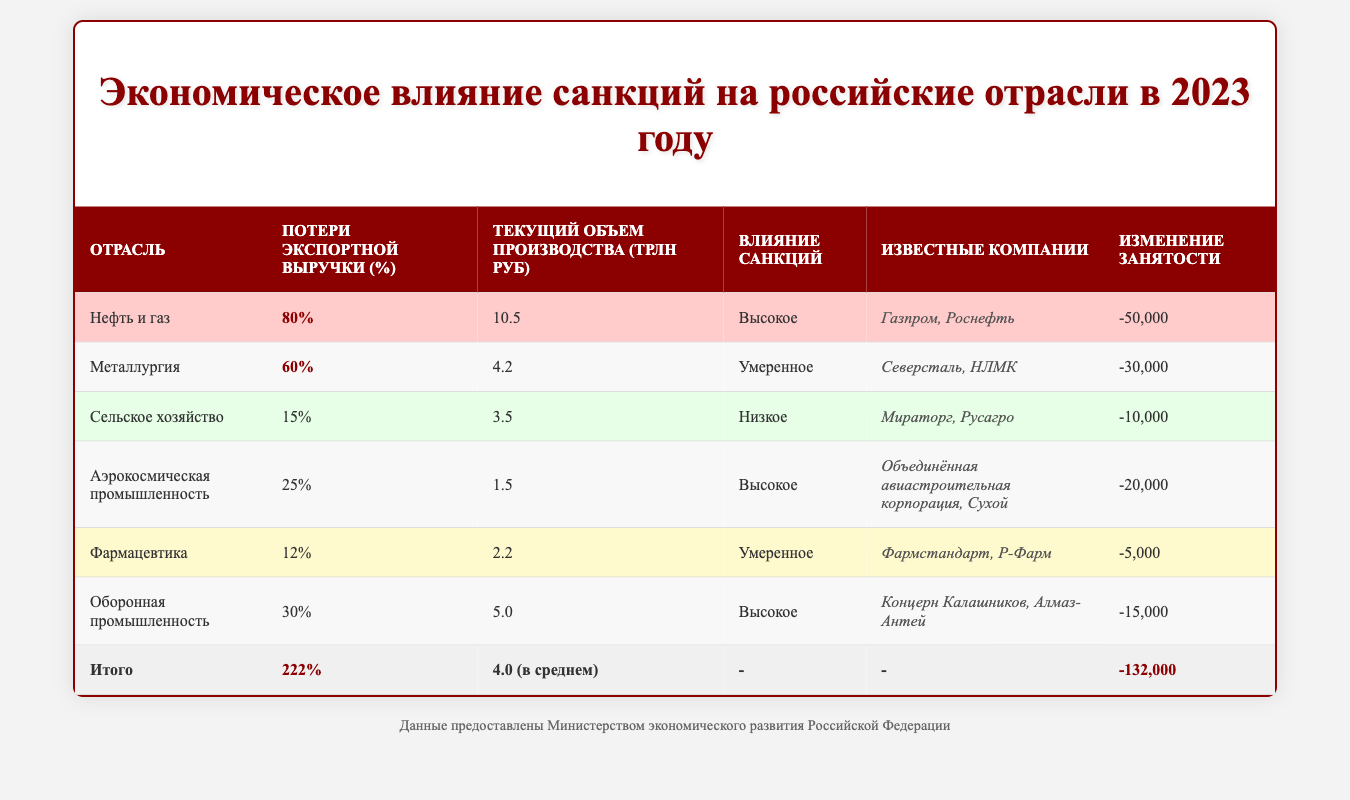What is the industry with the highest export revenue loss? The table indicates that the Oil and Gas industry has the highest export revenue loss at 80%.
Answer: Oil and Gas What is the total export revenue loss across all industries? By summing the export revenue loss of all industries: 80 + 60 + 15 + 25 + 12 + 30 = 222.
Answer: 222 Which industry has the lowest employment change? The Agriculture industry has the lowest employment change at -10,000.
Answer: Agriculture What is the average current output of the industries listed? The average current output can be calculated as (10.5 + 4.2 + 3.5 + 1.5 + 2.2 + 5.0) / 6 = 4.0 (in trillions of rubles).
Answer: 4.0 Which industry has the most severe impact from sanctions? The Oil and Gas, Aerospace, and Defense industries all have a "High" impact from sanctions, as indicated in the table.
Answer: Oil and Gas, Aerospace, Defense Is the export revenue loss for the Aerospace industry higher than that of the Pharmaceuticals industry? The Aerospace industry has an export revenue loss of 25%, while the Pharmaceuticals industry has a loss of 12%, so yes, 25% > 12%.
Answer: Yes What is the total employment change across all industries? By summing the employment changes: -50,000 + -30,000 + -10,000 + -20,000 + -5,000 + -15,000 = -132,000.
Answer: -132,000 Which industry contributes the least to current output? The Aerospace industry has the lowest current output at 1.5 trillion rubles compared to the others.
Answer: Aerospace Which two industries have a moderate impact from sanctions? The Metallurgy and Pharmaceuticals industries are classified as having a "Moderate" impact based on the table.
Answer: Metallurgy, Pharmaceuticals What is the combined export revenue loss of the Agriculture and Pharmaceuticals industries? The combined export revenue loss is calculated as 15 + 12 = 27%.
Answer: 27% 